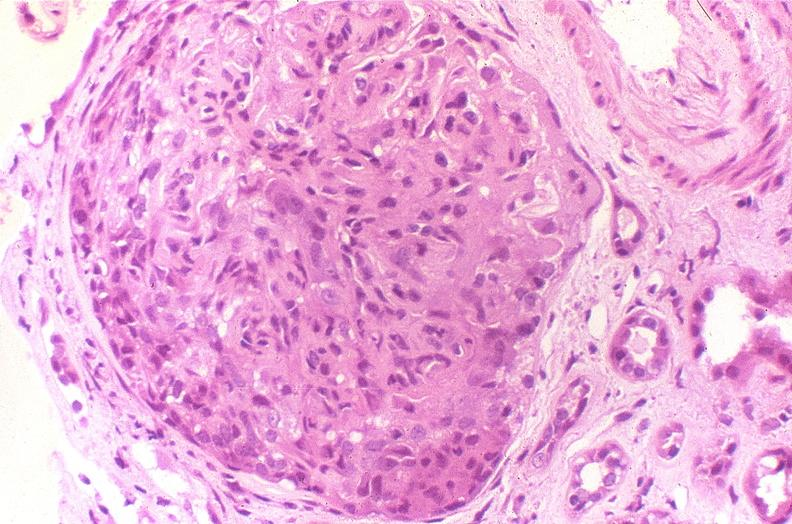does this image show glomerulonephritis, sle iv?
Answer the question using a single word or phrase. Yes 